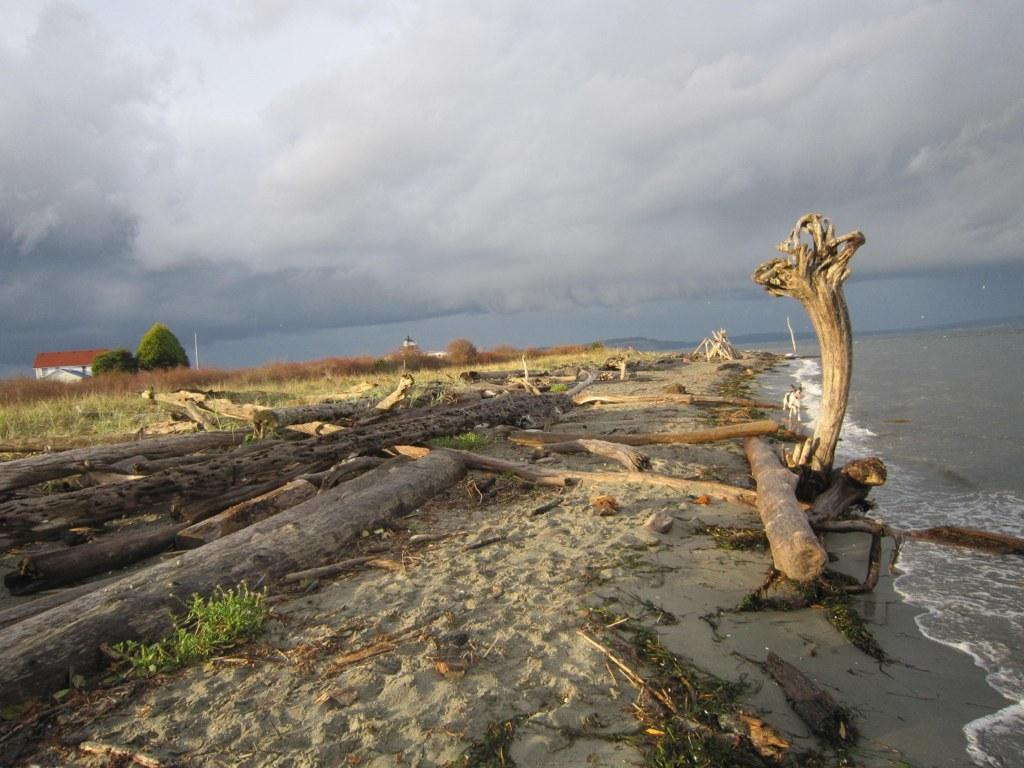What type of natural feature is on the right side of the image? There is a sea on the right side of the image. What objects are visible in the image that are made of wood? Trunks are visible in the image. What type of vegetation is present in the image? Grass is present in the image. What type of structure can be seen in the image? There is a house in the image. What other natural features are visible in the image? Trees are visible in the image. What is visible at the top of the image? The sky is visible at the top of the image. How many times does the grass fold in the image? The grass does not fold in the image; it is a static vegetation. What type of knot is tied around the trees in the image? There are no knots tied around the trees in the image. 